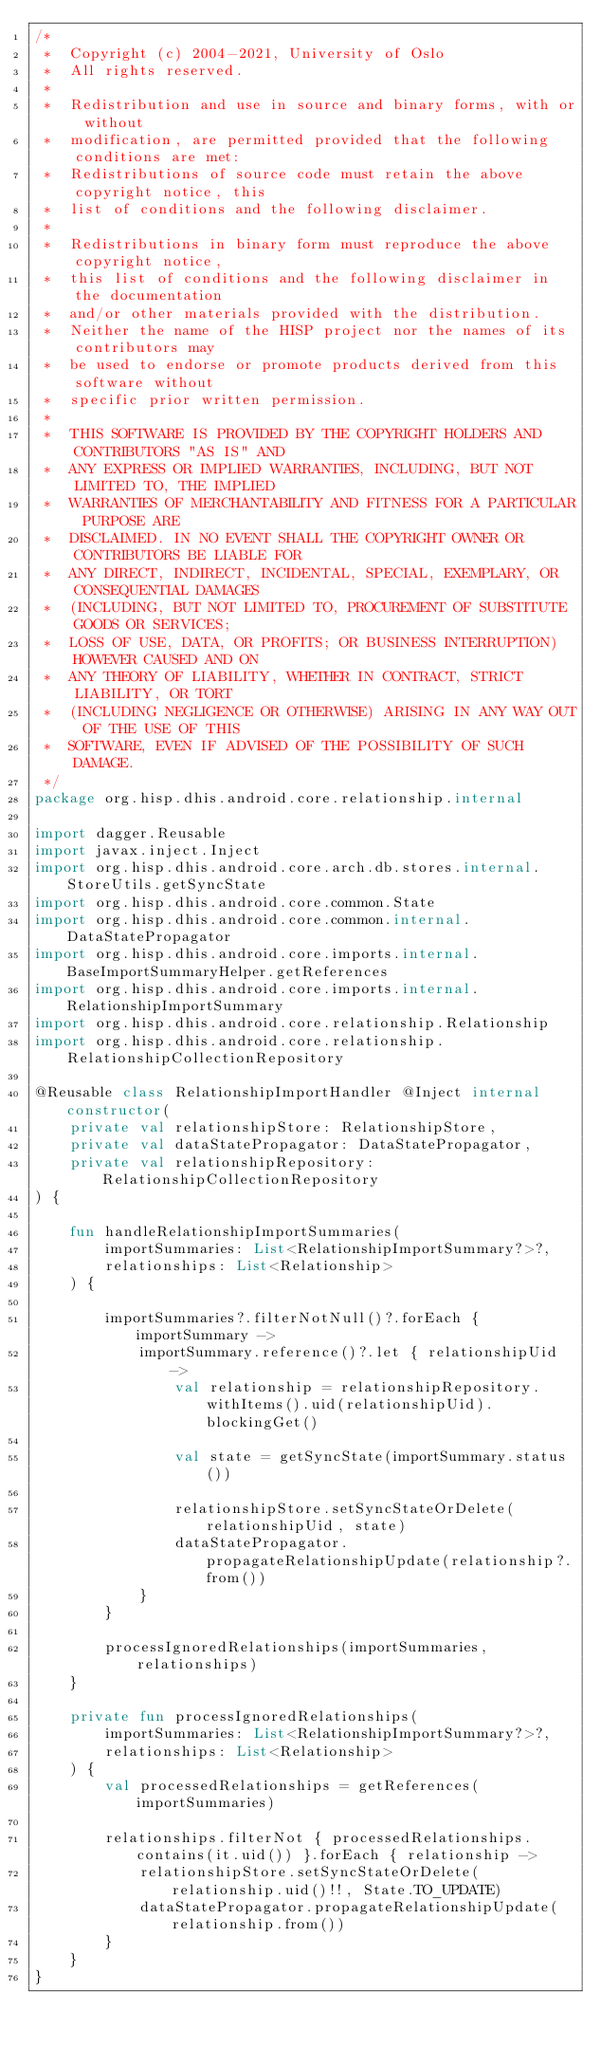<code> <loc_0><loc_0><loc_500><loc_500><_Kotlin_>/*
 *  Copyright (c) 2004-2021, University of Oslo
 *  All rights reserved.
 *
 *  Redistribution and use in source and binary forms, with or without
 *  modification, are permitted provided that the following conditions are met:
 *  Redistributions of source code must retain the above copyright notice, this
 *  list of conditions and the following disclaimer.
 *
 *  Redistributions in binary form must reproduce the above copyright notice,
 *  this list of conditions and the following disclaimer in the documentation
 *  and/or other materials provided with the distribution.
 *  Neither the name of the HISP project nor the names of its contributors may
 *  be used to endorse or promote products derived from this software without
 *  specific prior written permission.
 *
 *  THIS SOFTWARE IS PROVIDED BY THE COPYRIGHT HOLDERS AND CONTRIBUTORS "AS IS" AND
 *  ANY EXPRESS OR IMPLIED WARRANTIES, INCLUDING, BUT NOT LIMITED TO, THE IMPLIED
 *  WARRANTIES OF MERCHANTABILITY AND FITNESS FOR A PARTICULAR PURPOSE ARE
 *  DISCLAIMED. IN NO EVENT SHALL THE COPYRIGHT OWNER OR CONTRIBUTORS BE LIABLE FOR
 *  ANY DIRECT, INDIRECT, INCIDENTAL, SPECIAL, EXEMPLARY, OR CONSEQUENTIAL DAMAGES
 *  (INCLUDING, BUT NOT LIMITED TO, PROCUREMENT OF SUBSTITUTE GOODS OR SERVICES;
 *  LOSS OF USE, DATA, OR PROFITS; OR BUSINESS INTERRUPTION) HOWEVER CAUSED AND ON
 *  ANY THEORY OF LIABILITY, WHETHER IN CONTRACT, STRICT LIABILITY, OR TORT
 *  (INCLUDING NEGLIGENCE OR OTHERWISE) ARISING IN ANY WAY OUT OF THE USE OF THIS
 *  SOFTWARE, EVEN IF ADVISED OF THE POSSIBILITY OF SUCH DAMAGE.
 */
package org.hisp.dhis.android.core.relationship.internal

import dagger.Reusable
import javax.inject.Inject
import org.hisp.dhis.android.core.arch.db.stores.internal.StoreUtils.getSyncState
import org.hisp.dhis.android.core.common.State
import org.hisp.dhis.android.core.common.internal.DataStatePropagator
import org.hisp.dhis.android.core.imports.internal.BaseImportSummaryHelper.getReferences
import org.hisp.dhis.android.core.imports.internal.RelationshipImportSummary
import org.hisp.dhis.android.core.relationship.Relationship
import org.hisp.dhis.android.core.relationship.RelationshipCollectionRepository

@Reusable class RelationshipImportHandler @Inject internal constructor(
    private val relationshipStore: RelationshipStore,
    private val dataStatePropagator: DataStatePropagator,
    private val relationshipRepository: RelationshipCollectionRepository
) {

    fun handleRelationshipImportSummaries(
        importSummaries: List<RelationshipImportSummary?>?,
        relationships: List<Relationship>
    ) {

        importSummaries?.filterNotNull()?.forEach { importSummary ->
            importSummary.reference()?.let { relationshipUid ->
                val relationship = relationshipRepository.withItems().uid(relationshipUid).blockingGet()

                val state = getSyncState(importSummary.status())

                relationshipStore.setSyncStateOrDelete(relationshipUid, state)
                dataStatePropagator.propagateRelationshipUpdate(relationship?.from())
            }
        }

        processIgnoredRelationships(importSummaries, relationships)
    }

    private fun processIgnoredRelationships(
        importSummaries: List<RelationshipImportSummary?>?,
        relationships: List<Relationship>
    ) {
        val processedRelationships = getReferences(importSummaries)

        relationships.filterNot { processedRelationships.contains(it.uid()) }.forEach { relationship ->
            relationshipStore.setSyncStateOrDelete(relationship.uid()!!, State.TO_UPDATE)
            dataStatePropagator.propagateRelationshipUpdate(relationship.from())
        }
    }
}
</code> 